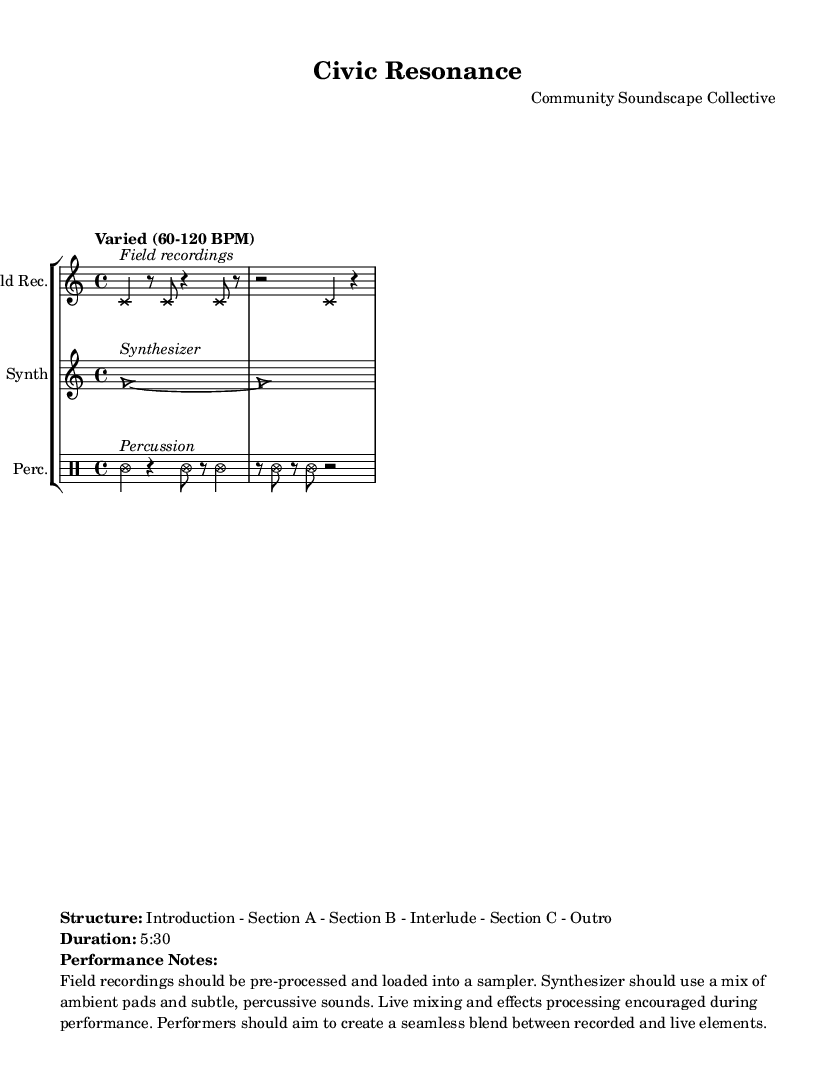What is the title of this composition? The title is indicated in the header of the sheet music.
Answer: Civic Resonance What is the time signature used in this music? The music indicates a time signature of 4/4, which is shown in the global section.
Answer: 4/4 What is the tempo range specified for the piece? The tempo is noted to be "Varied (60-120 BPM)" in the global section.
Answer: Varied (60-120 BPM) How many sections are outlined in the structure of the piece? The structure includes six sections: Introduction, Section A, Section B, Interlude, Section C, and Outro, as stated in the markup.
Answer: 6 What is the duration of the performance? The duration is provided in the markup, explicitly stating "5:30".
Answer: 5:30 What type of notehead is used for field recordings? The notehead style for field recordings is indicated as 'cross', as shown in the fieldRecordings section.
Answer: Cross What performance aspect is encouraged during this piece? The markup mentions that "Live mixing and effects processing encouraged during performance," highlighting an important performance consideration.
Answer: Live mixing and effects processing 